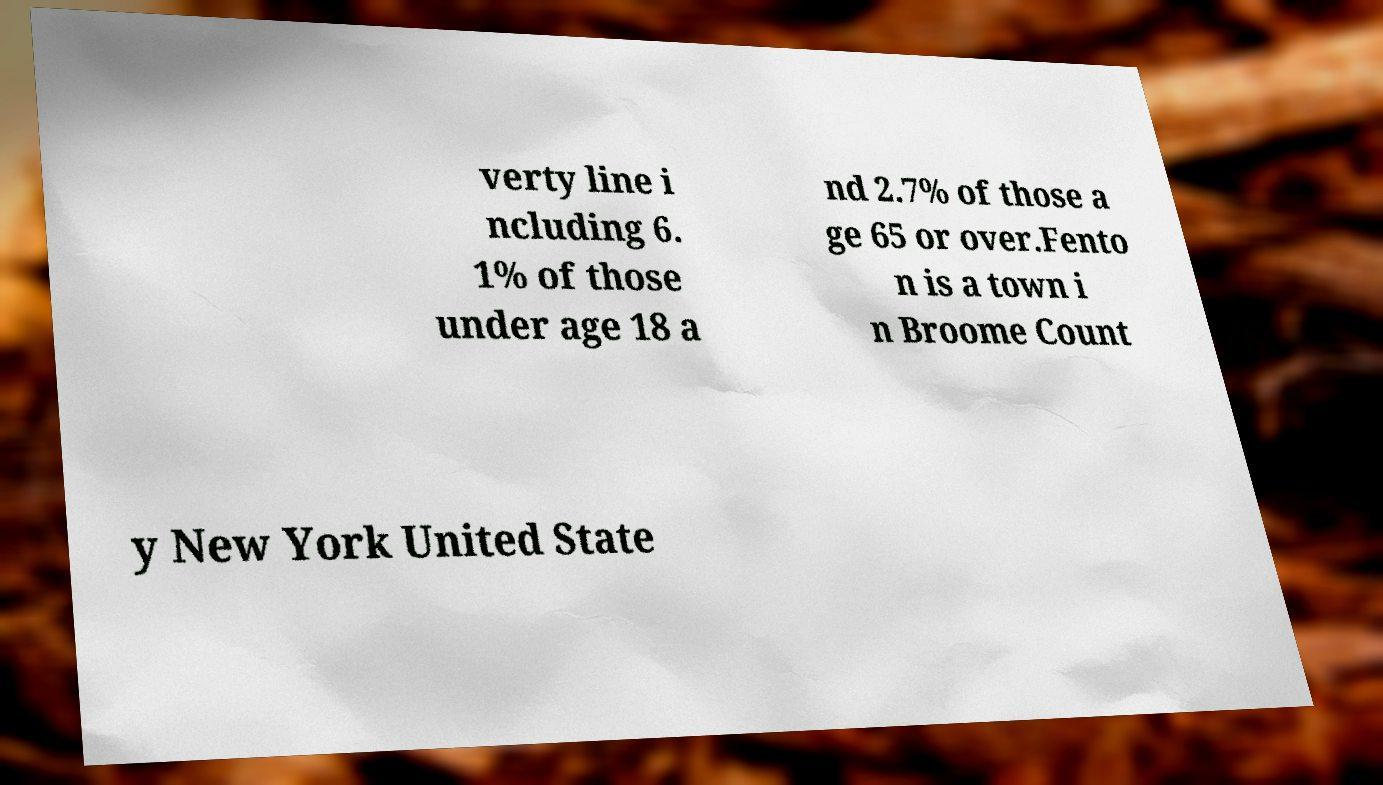Could you extract and type out the text from this image? verty line i ncluding 6. 1% of those under age 18 a nd 2.7% of those a ge 65 or over.Fento n is a town i n Broome Count y New York United State 